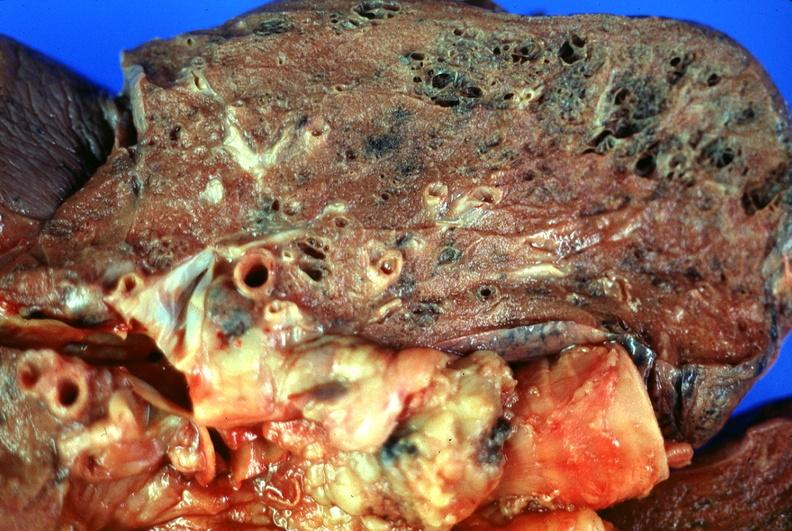what is present?
Answer the question using a single word or phrase. Respiratory 